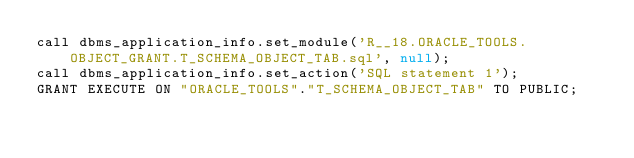<code> <loc_0><loc_0><loc_500><loc_500><_SQL_>call dbms_application_info.set_module('R__18.ORACLE_TOOLS.OBJECT_GRANT.T_SCHEMA_OBJECT_TAB.sql', null);
call dbms_application_info.set_action('SQL statement 1');
GRANT EXECUTE ON "ORACLE_TOOLS"."T_SCHEMA_OBJECT_TAB" TO PUBLIC;

</code> 